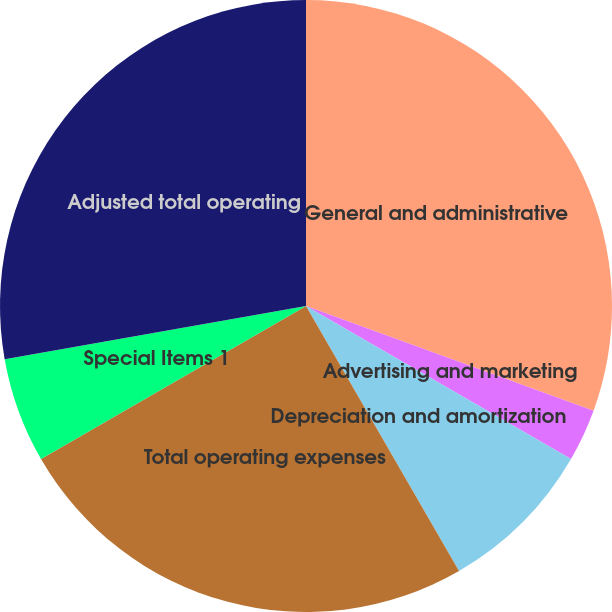Convert chart to OTSL. <chart><loc_0><loc_0><loc_500><loc_500><pie_chart><fcel>General and administrative<fcel>Advertising and marketing<fcel>Depreciation and amortization<fcel>Total operating expenses<fcel>Special Items 1<fcel>Adjusted total operating<nl><fcel>30.56%<fcel>2.78%<fcel>8.33%<fcel>25.0%<fcel>5.56%<fcel>27.78%<nl></chart> 